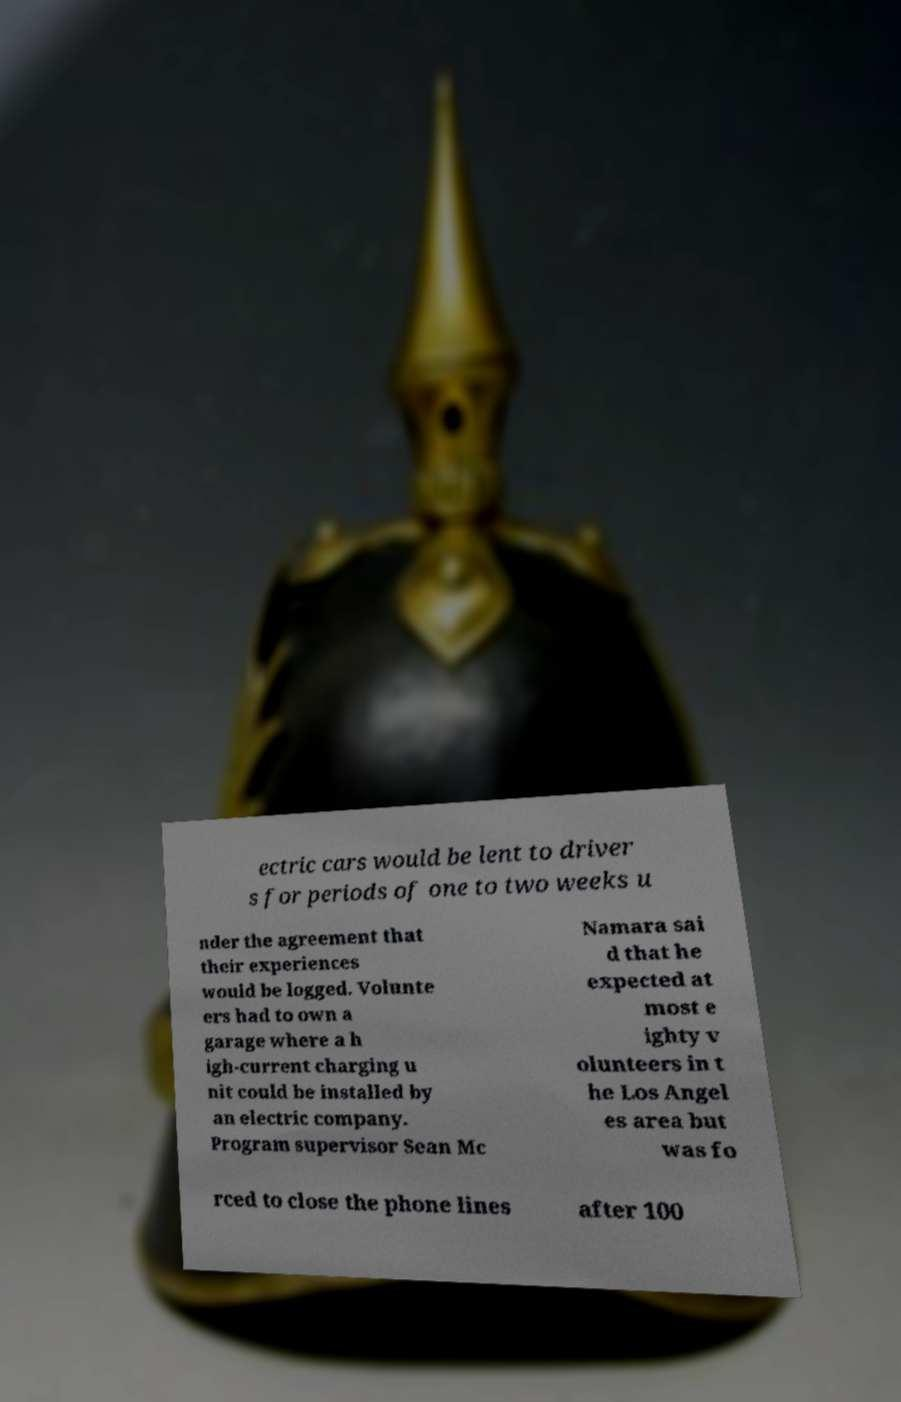Can you accurately transcribe the text from the provided image for me? ectric cars would be lent to driver s for periods of one to two weeks u nder the agreement that their experiences would be logged. Volunte ers had to own a garage where a h igh-current charging u nit could be installed by an electric company. Program supervisor Sean Mc Namara sai d that he expected at most e ighty v olunteers in t he Los Angel es area but was fo rced to close the phone lines after 100 